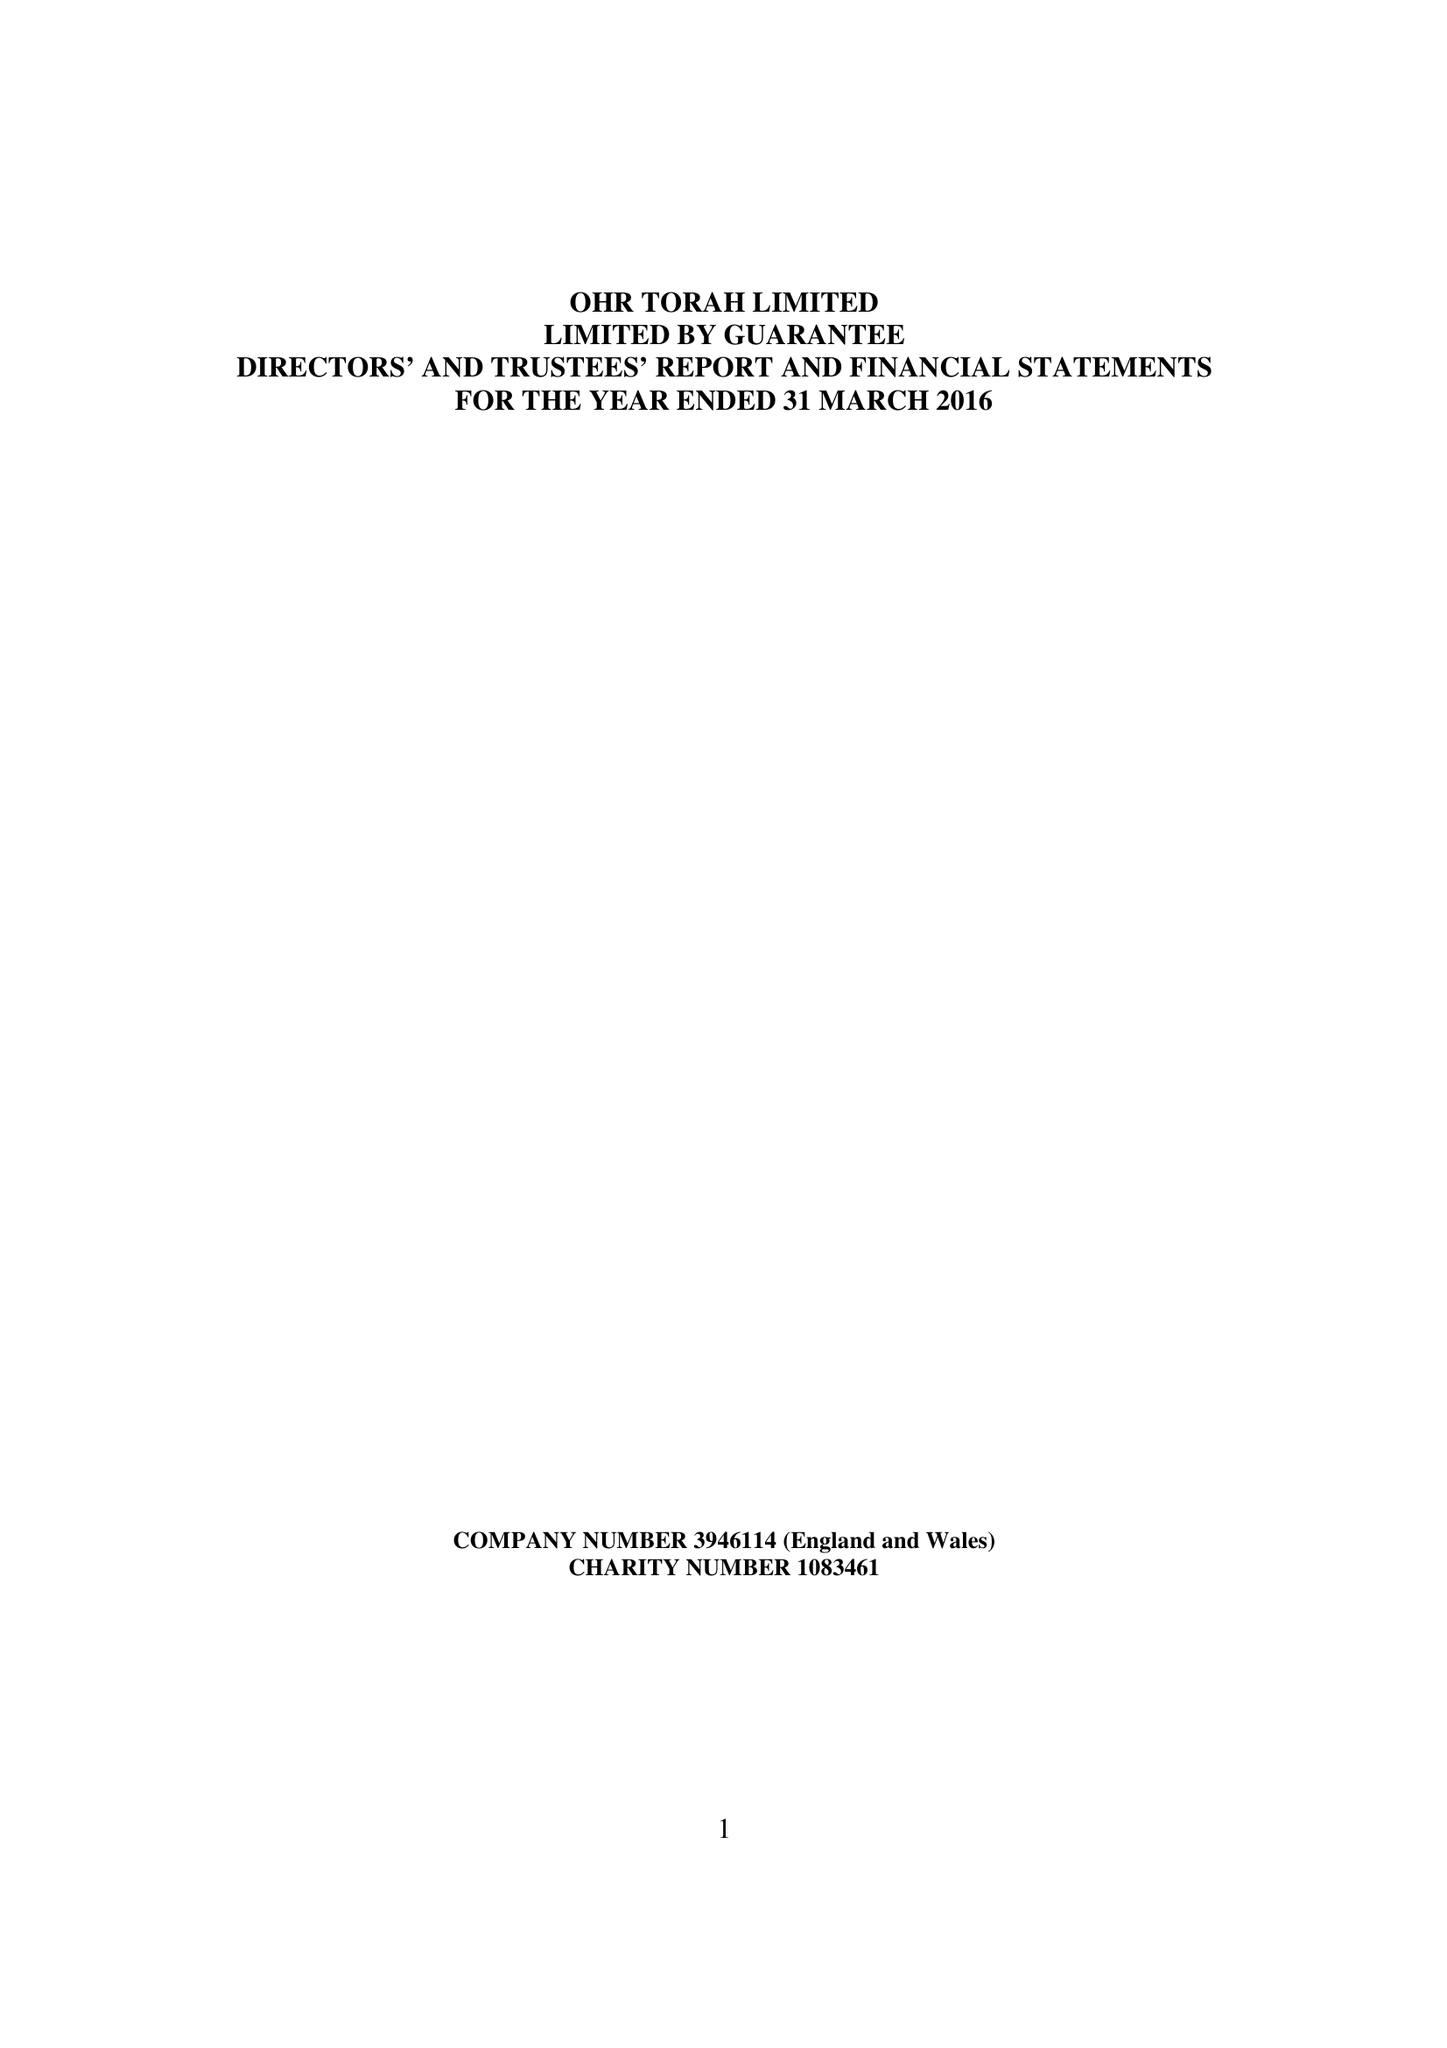What is the value for the charity_number?
Answer the question using a single word or phrase. 1083461 